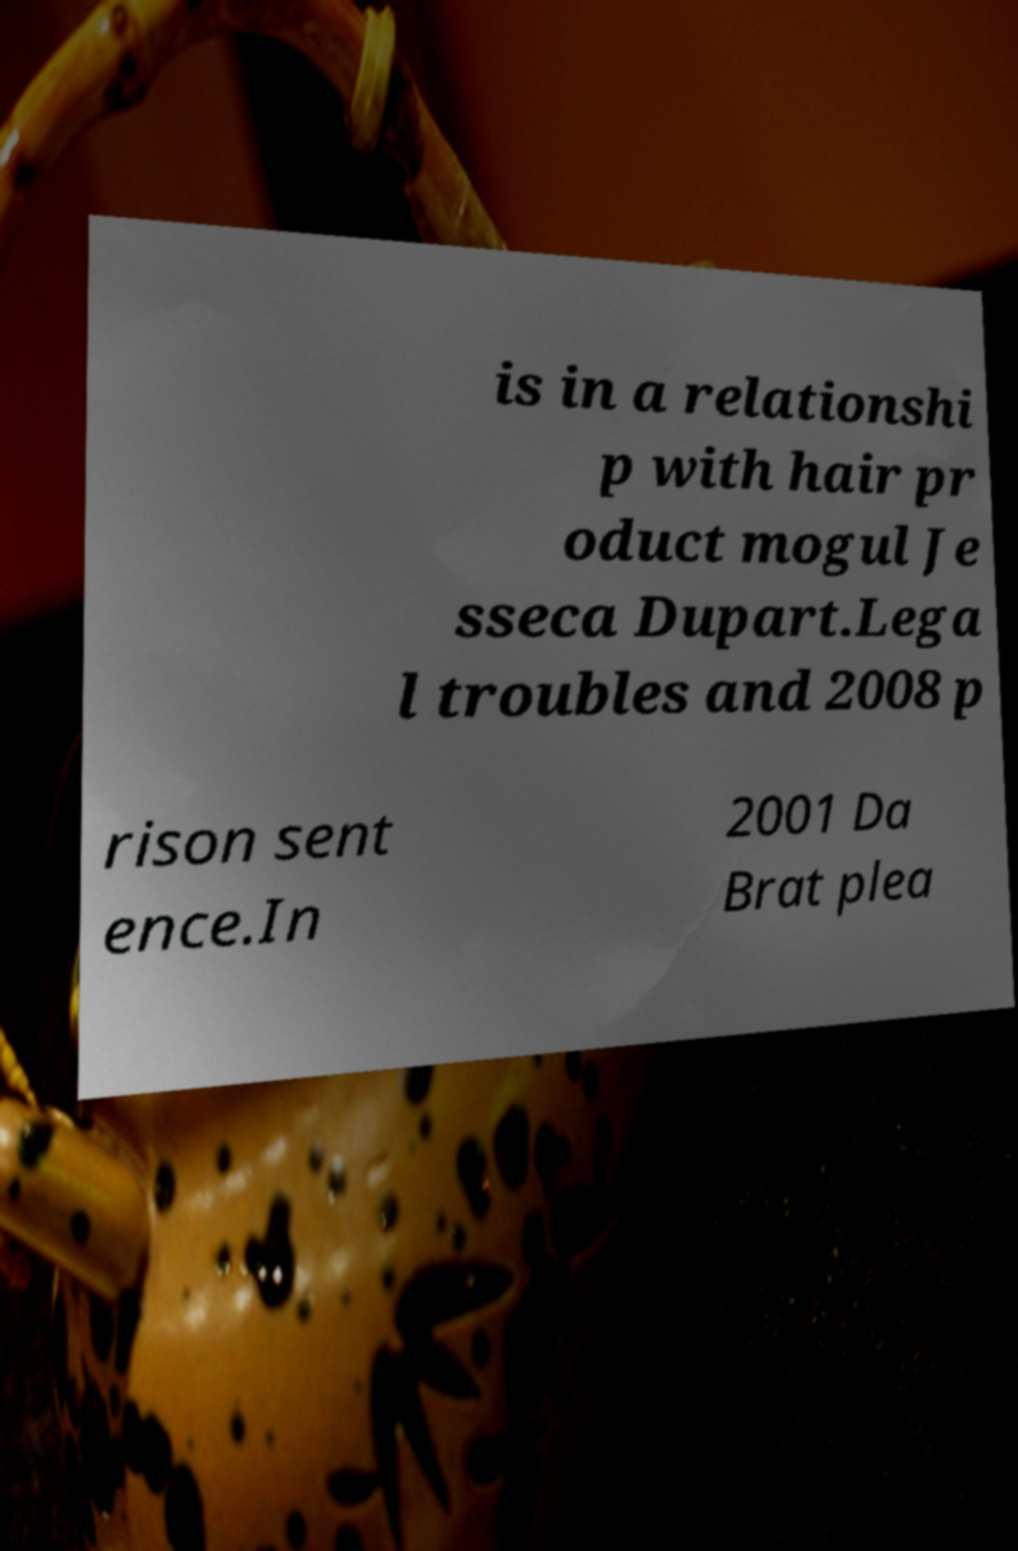Please identify and transcribe the text found in this image. is in a relationshi p with hair pr oduct mogul Je sseca Dupart.Lega l troubles and 2008 p rison sent ence.In 2001 Da Brat plea 